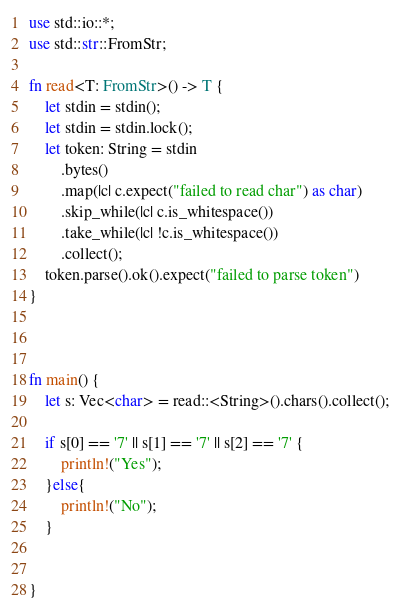<code> <loc_0><loc_0><loc_500><loc_500><_Rust_>use std::io::*;
use std::str::FromStr;

fn read<T: FromStr>() -> T {
    let stdin = stdin();
    let stdin = stdin.lock();
    let token: String = stdin
        .bytes()
        .map(|c| c.expect("failed to read char") as char) 
        .skip_while(|c| c.is_whitespace())
        .take_while(|c| !c.is_whitespace())
        .collect();
    token.parse().ok().expect("failed to parse token")
}



fn main() {
    let s: Vec<char> = read::<String>().chars().collect();

    if s[0] == '7' || s[1] == '7' || s[2] == '7' {
        println!("Yes");
    }else{
        println!("No");
    }


}
</code> 